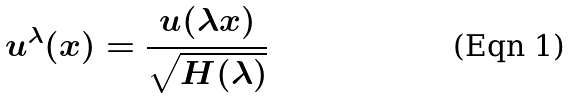Convert formula to latex. <formula><loc_0><loc_0><loc_500><loc_500>u ^ { \lambda } ( x ) = \frac { u ( \lambda x ) } { \sqrt { H ( \lambda ) } }</formula> 